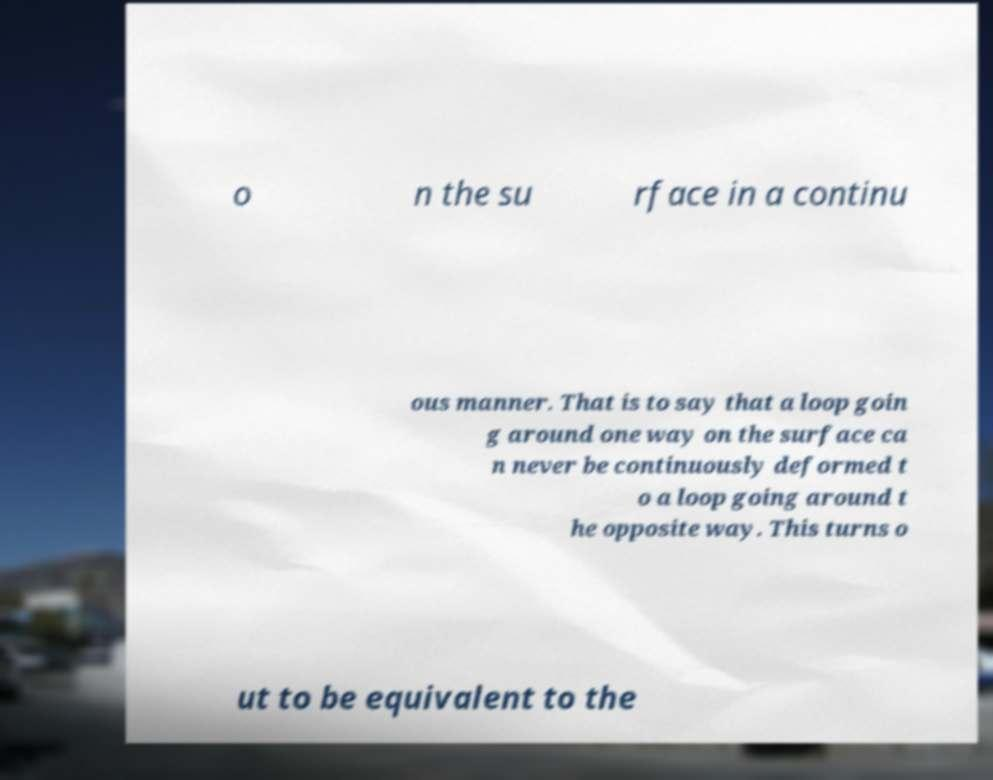There's text embedded in this image that I need extracted. Can you transcribe it verbatim? o n the su rface in a continu ous manner. That is to say that a loop goin g around one way on the surface ca n never be continuously deformed t o a loop going around t he opposite way. This turns o ut to be equivalent to the 